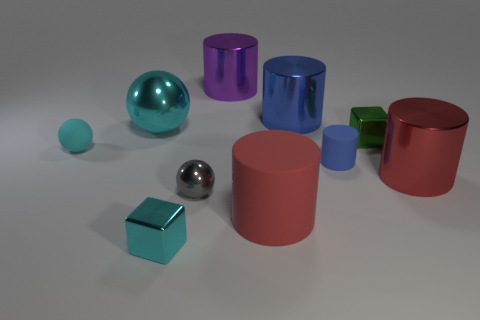What number of balls are either big objects or tiny cyan objects?
Your answer should be very brief. 2. Is the tiny green thing made of the same material as the big sphere?
Offer a terse response. Yes. What number of other objects are the same color as the tiny cylinder?
Give a very brief answer. 1. What shape is the big red thing to the right of the big blue metal cylinder?
Offer a terse response. Cylinder. How many objects are tiny matte cubes or big purple metallic cylinders?
Ensure brevity in your answer.  1. There is a green shiny block; does it have the same size as the red cylinder in front of the small gray shiny ball?
Give a very brief answer. No. What number of other things are there of the same material as the cyan cube
Give a very brief answer. 6. How many things are either tiny green metal objects right of the tiny blue cylinder or large objects right of the large sphere?
Provide a short and direct response. 5. What is the material of the other tiny object that is the same shape as the tiny gray thing?
Make the answer very short. Rubber. Are there any red spheres?
Provide a short and direct response. No. 